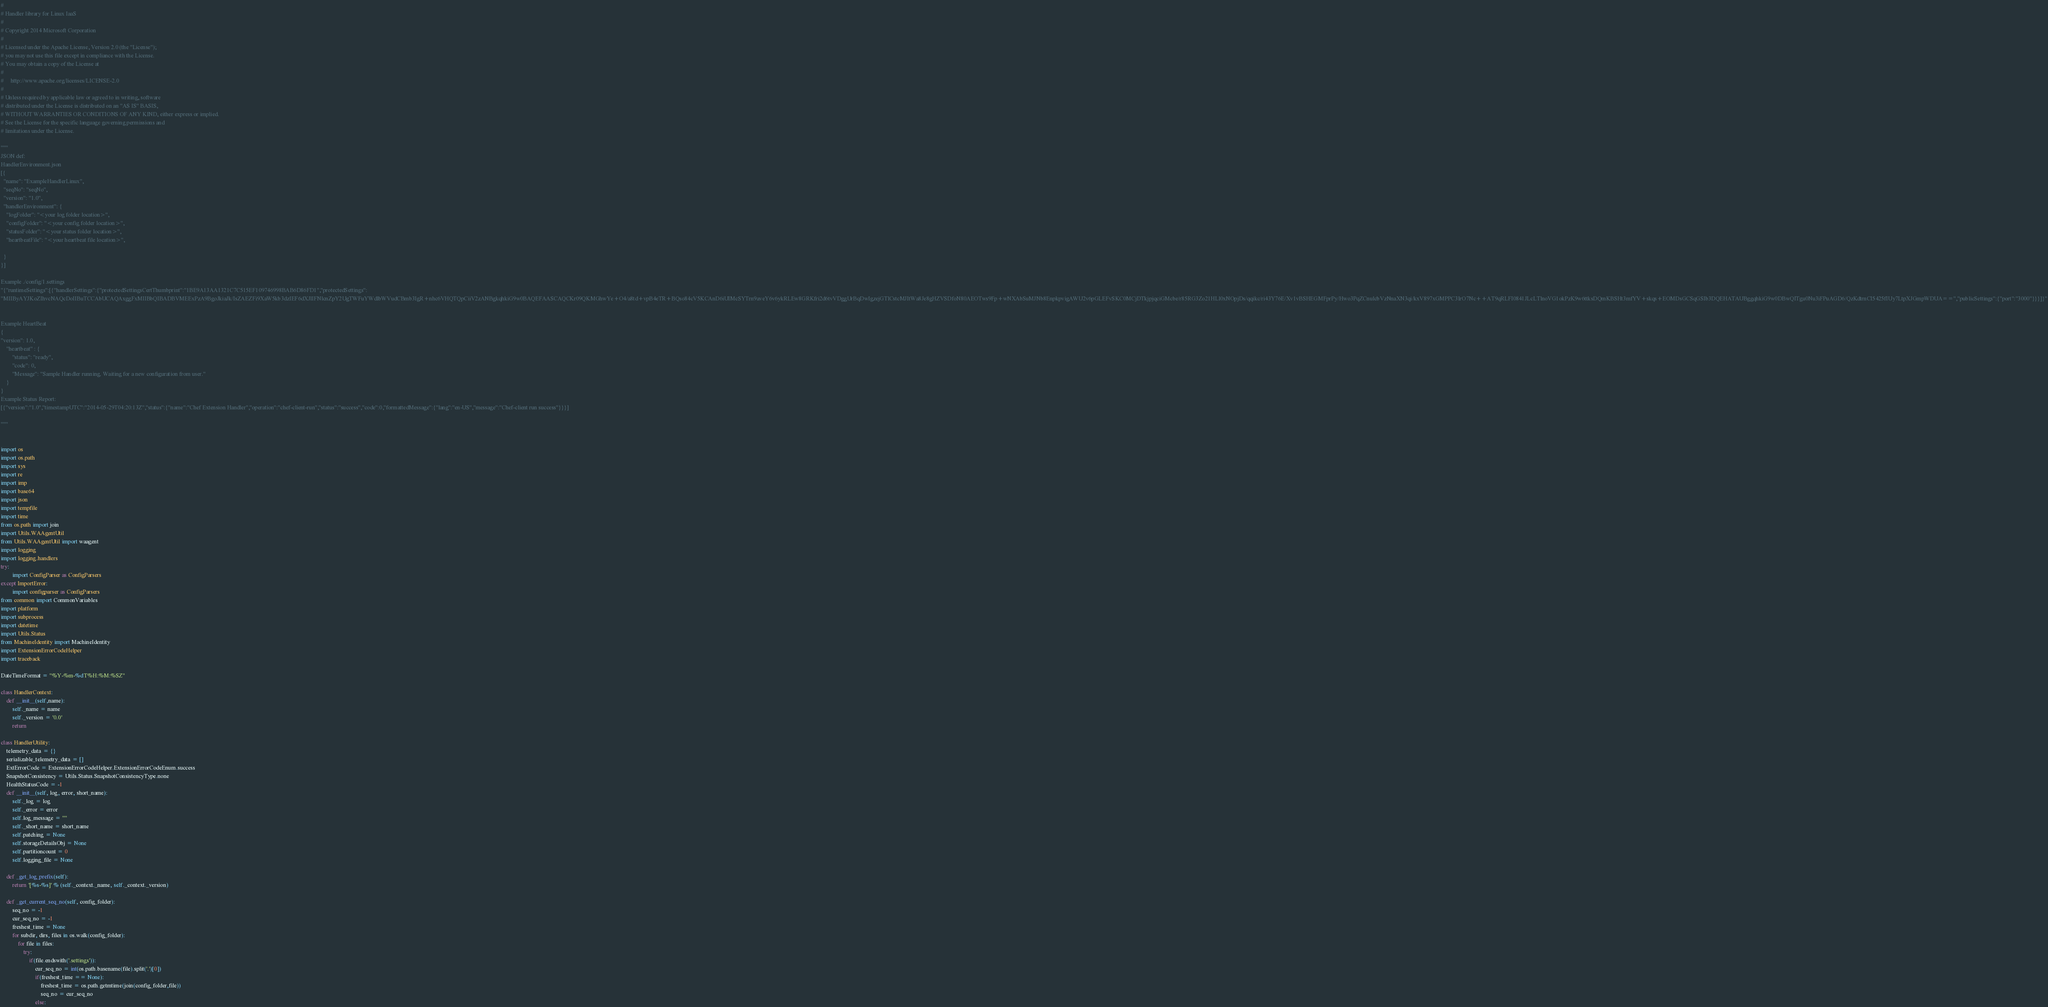Convert code to text. <code><loc_0><loc_0><loc_500><loc_500><_Python_>#
# Handler library for Linux IaaS
#
# Copyright 2014 Microsoft Corporation
#
# Licensed under the Apache License, Version 2.0 (the "License");
# you may not use this file except in compliance with the License.
# You may obtain a copy of the License at
#
#     http://www.apache.org/licenses/LICENSE-2.0
#
# Unless required by applicable law or agreed to in writing, software
# distributed under the License is distributed on an "AS IS" BASIS,
# WITHOUT WARRANTIES OR CONDITIONS OF ANY KIND, either express or implied.
# See the License for the specific language governing permissions and
# limitations under the License.

"""
JSON def:
HandlerEnvironment.json
[{
  "name": "ExampleHandlerLinux",
  "seqNo": "seqNo",
  "version": "1.0",
  "handlerEnvironment": {
    "logFolder": "<your log folder location>",
    "configFolder": "<your config folder location>",
    "statusFolder": "<your status folder location>",
    "heartbeatFile": "<your heartbeat file location>",
    
  }
}]

Example ./config/1.settings
"{"runtimeSettings":[{"handlerSettings":{"protectedSettingsCertThumbprint":"1BE9A13AA1321C7C515EF109746998BAB6D86FD1","protectedSettings":
"MIIByAYJKoZIhvcNAQcDoIIBuTCCAbUCAQAxggFxMIIBbQIBADBVMEExPzA9BgoJkiaJk/IsZAEZFi9XaW5kb3dzIEF6dXJlIFNlcnZpY2UgTWFuYWdlbWVudCBmb3IgR+nhc6VHQTQpCiiV2zANBgkqhkiG9w0BAQEFAASCAQCKr09QKMGhwYe+O4/a8td+vpB4eTR+BQso84cV5KCAnD6iUIMcSYTrn9aveY6v6ykRLEw8GRKfri2d6tvVDggUrBqDwIgzejGTlCstcMJItWa8Je8gHZVSDfoN80AEOTws9Fp+wNXAbSuMJNb8EnpkpvigAWU2v6pGLEFvSKC0MCjDTkjpjqciGMcbe/r85RG3Zo21HLl0xNOpjDs/qqikc/ri43Y76E/Xv1vBSHEGMFprPy/Hwo3PqZCnulcbVzNnaXN3qi/kxV897xGMPPC3IrO7Nc++AT9qRLFI0841JLcLTlnoVG1okPzK9w6ttksDQmKBSHt3mfYV+skqs+EOMDsGCSqGSIb3DQEHATAUBggqhkiG9w0DBwQITgu0Nu3iFPuAGD6/QzKdtrnCI5425fIUy7LtpXJGmpWDUA==","publicSettings":{"port":"3000"}}}]}"


Example HeartBeat
{
"version": 1.0,
    "heartbeat" : {
        "status": "ready",
        "code": 0,
        "Message": "Sample Handler running. Waiting for a new configuration from user."
    }
}
Example Status Report:
[{"version":"1.0","timestampUTC":"2014-05-29T04:20:13Z","status":{"name":"Chef Extension Handler","operation":"chef-client-run","status":"success","code":0,"formattedMessage":{"lang":"en-US","message":"Chef-client run success"}}}]

"""


import os
import os.path
import sys
import re
import imp
import base64
import json
import tempfile
import time
from os.path import join
import Utils.WAAgentUtil
from Utils.WAAgentUtil import waagent
import logging
import logging.handlers
try:
        import ConfigParser as ConfigParsers
except ImportError:
        import configparser as ConfigParsers
from common import CommonVariables
import platform
import subprocess
import datetime
import Utils.Status
from MachineIdentity import MachineIdentity
import ExtensionErrorCodeHelper
import traceback

DateTimeFormat = "%Y-%m-%dT%H:%M:%SZ"

class HandlerContext:
    def __init__(self,name):
        self._name = name
        self._version = '0.0'
        return

class HandlerUtility:
    telemetry_data = {} 
    serializable_telemetry_data = []
    ExtErrorCode = ExtensionErrorCodeHelper.ExtensionErrorCodeEnum.success
    SnapshotConsistency = Utils.Status.SnapshotConsistencyType.none
    HealthStatusCode = -1
    def __init__(self, log, error, short_name):
        self._log = log
        self._error = error
        self.log_message = ""
        self._short_name = short_name
        self.patching = None
        self.storageDetailsObj = None
        self.partitioncount = 0
        self.logging_file = None

    def _get_log_prefix(self):
        return '[%s-%s]' % (self._context._name, self._context._version)

    def _get_current_seq_no(self, config_folder):
        seq_no = -1
        cur_seq_no = -1
        freshest_time = None
        for subdir, dirs, files in os.walk(config_folder):
            for file in files:
                try:
                    if(file.endswith('.settings')):
                        cur_seq_no = int(os.path.basename(file).split('.')[0])
                        if(freshest_time == None):
                            freshest_time = os.path.getmtime(join(config_folder,file))
                            seq_no = cur_seq_no
                        else:</code> 